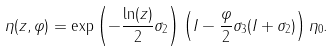<formula> <loc_0><loc_0><loc_500><loc_500>\eta ( z , \varphi ) = \exp \left ( - \frac { \ln ( z ) } { 2 } \sigma _ { 2 } \right ) \left ( I - \frac { \varphi } { 2 } \sigma _ { 3 } ( I + \sigma _ { 2 } ) \right ) \eta _ { 0 } .</formula> 